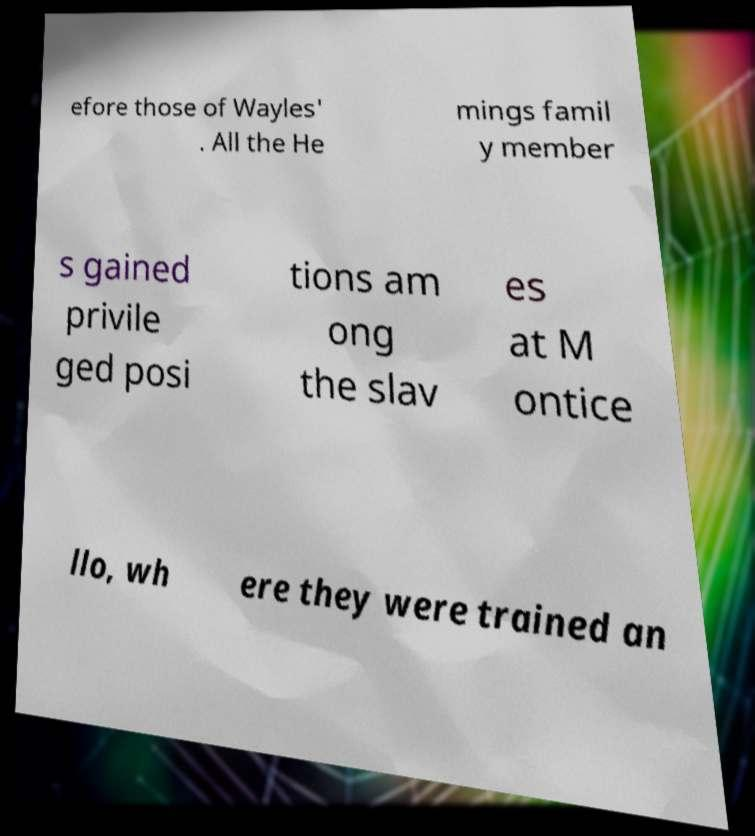Please read and relay the text visible in this image. What does it say? efore those of Wayles' . All the He mings famil y member s gained privile ged posi tions am ong the slav es at M ontice llo, wh ere they were trained an 